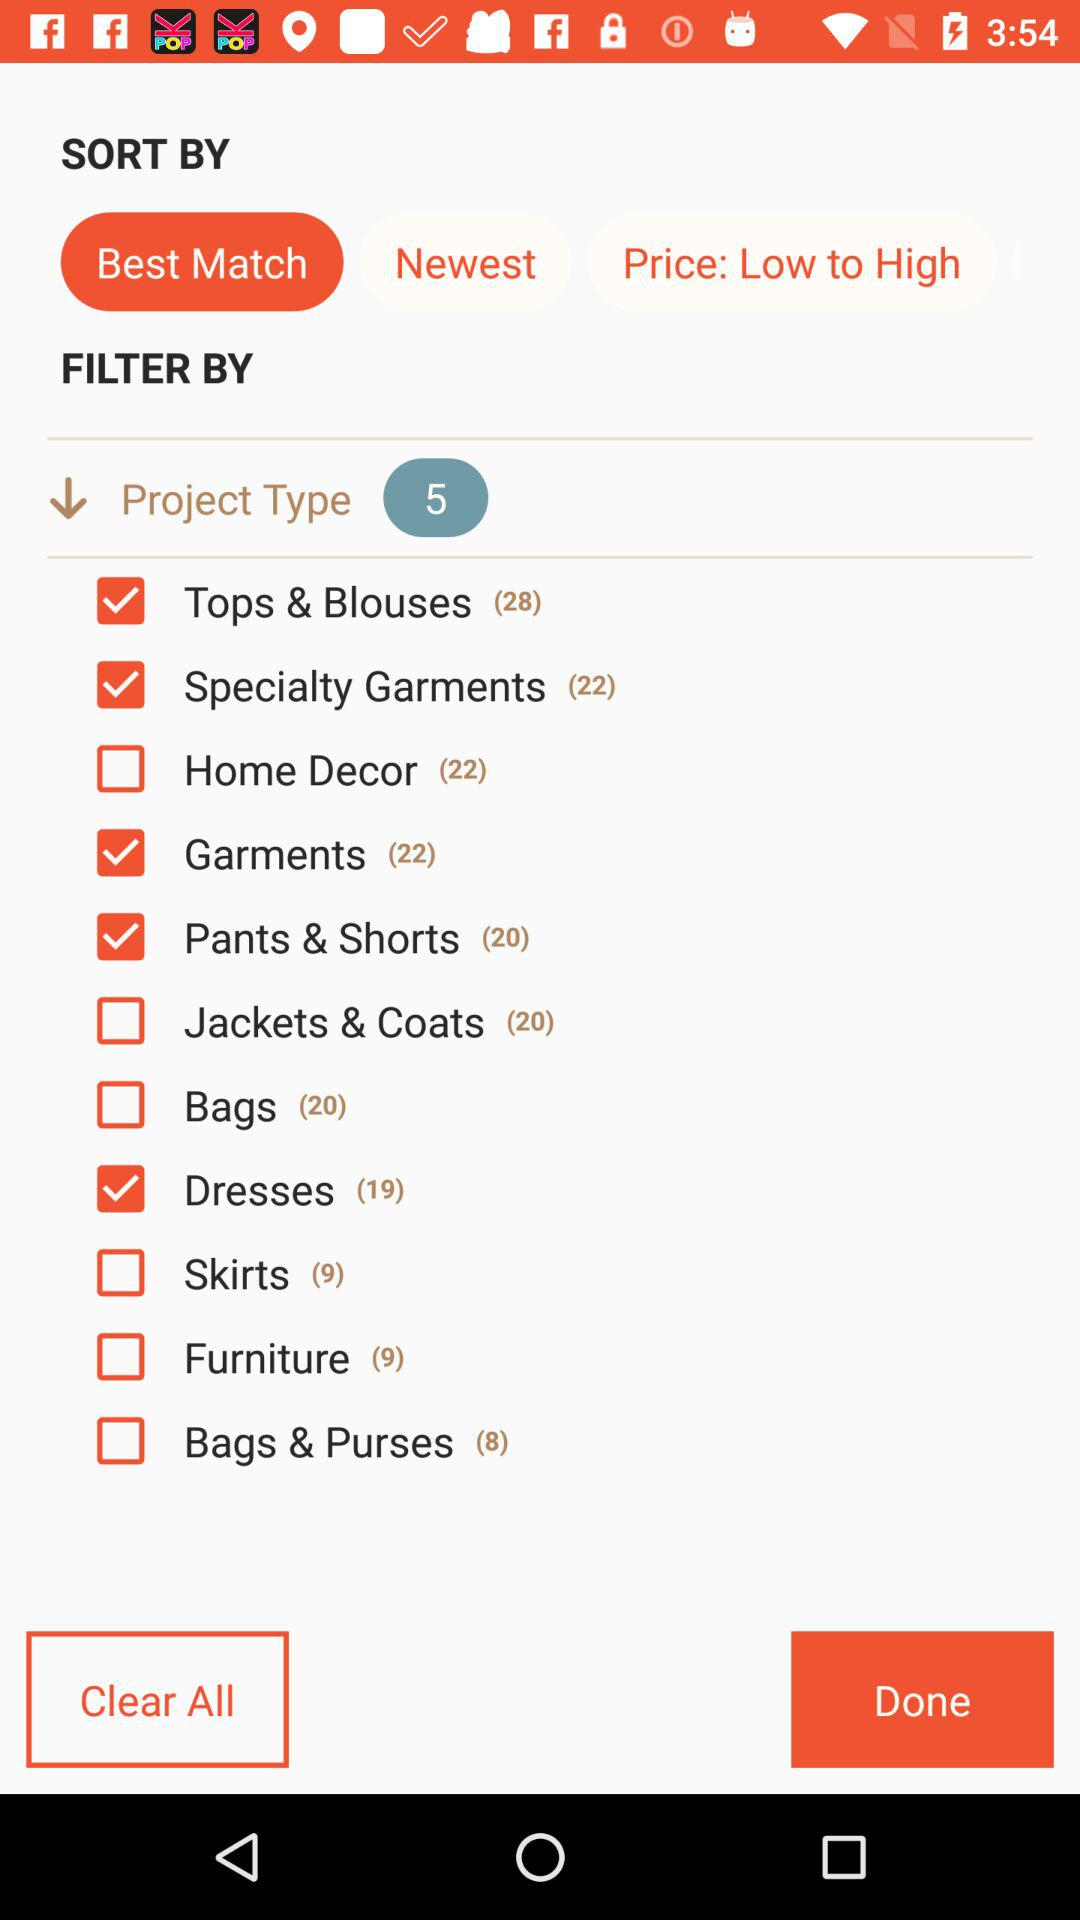What is the total number of "Project Type" selected? The total number is 5. 